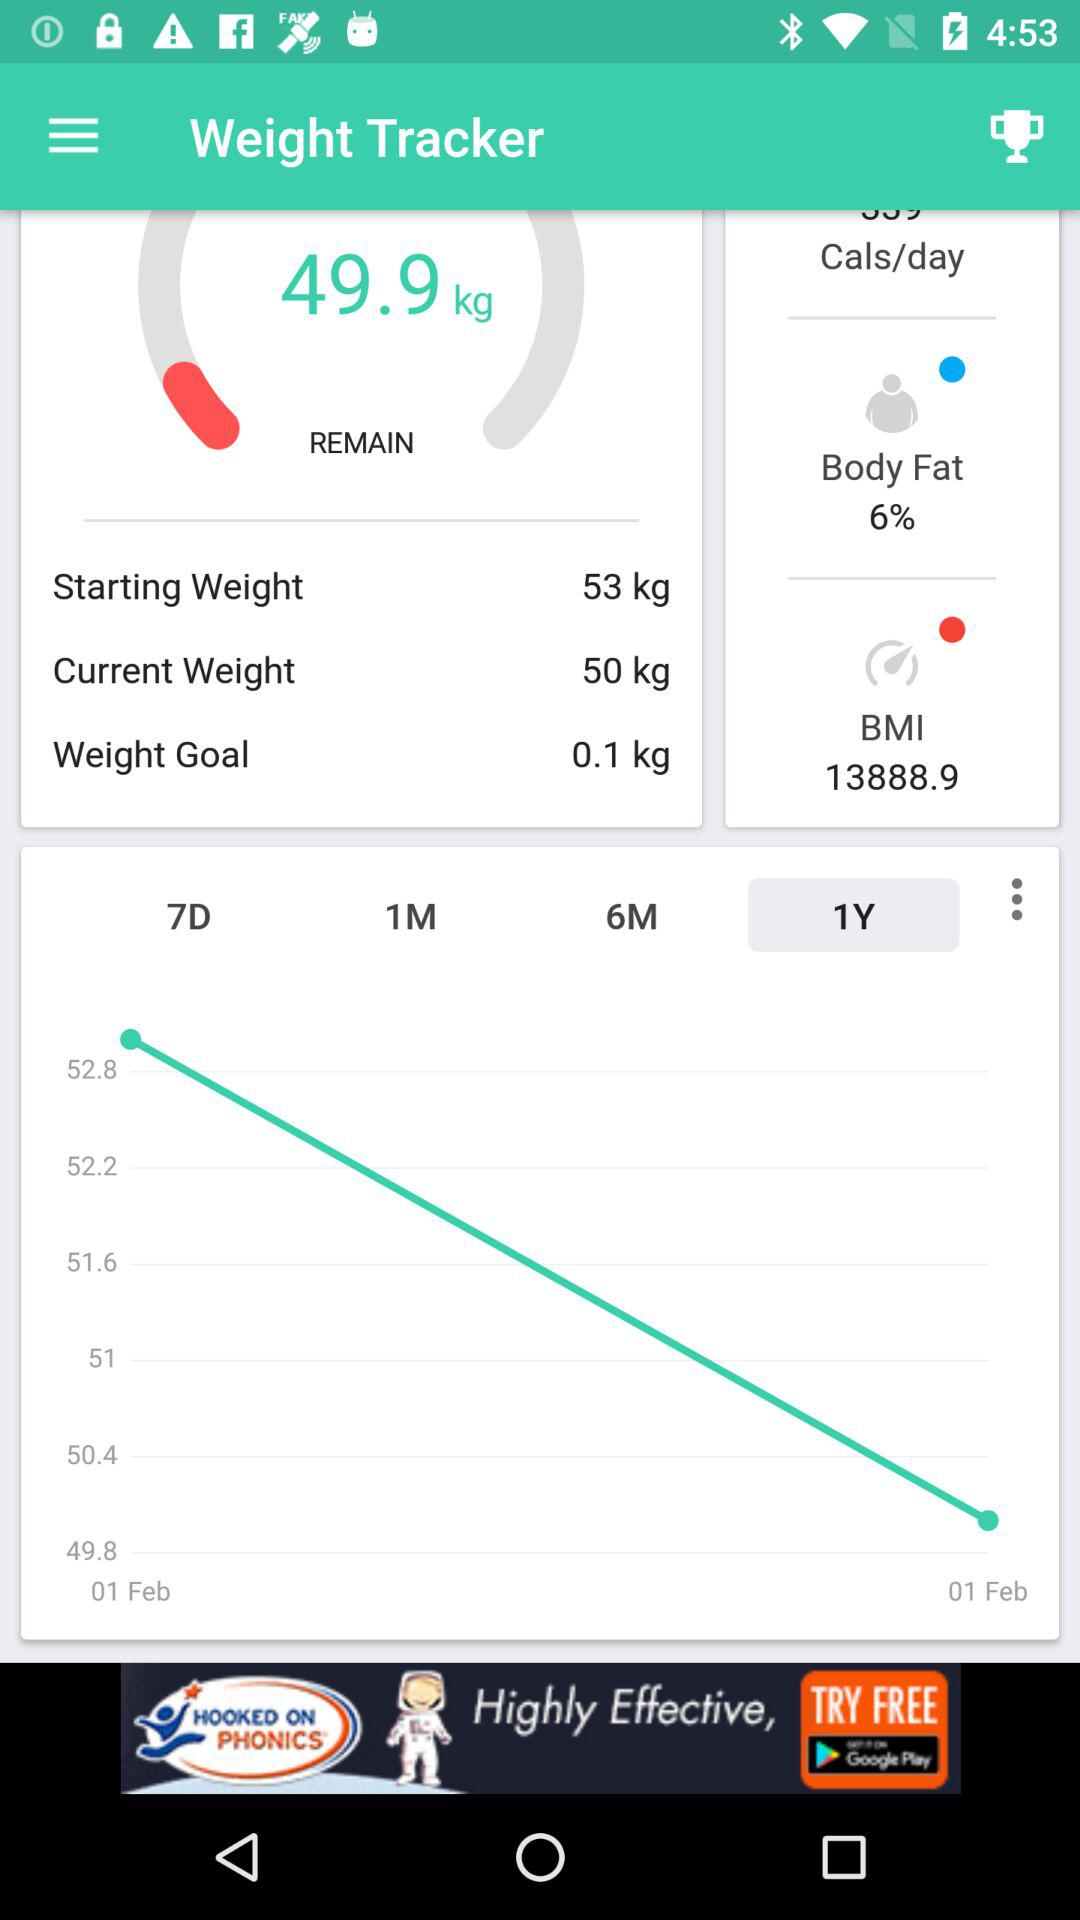The weight tracker starts from which date?
When the provided information is insufficient, respond with <no answer>. <no answer> 